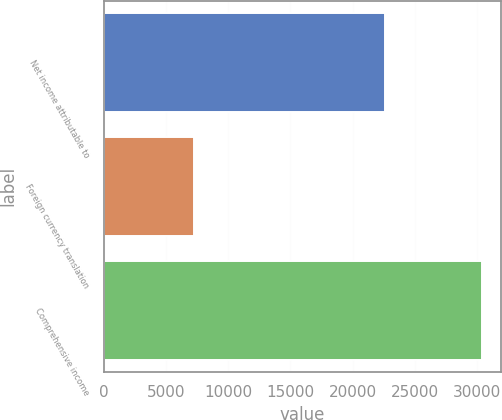Convert chart to OTSL. <chart><loc_0><loc_0><loc_500><loc_500><bar_chart><fcel>Net income attributable to<fcel>Foreign currency translation<fcel>Comprehensive income<nl><fcel>22588<fcel>7217<fcel>30378<nl></chart> 